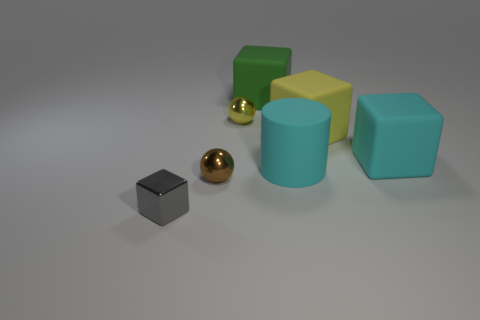Are there an equal number of tiny cubes that are in front of the big yellow matte thing and brown spheres in front of the tiny gray block?
Offer a very short reply. No. There is a metal ball behind the tiny sphere that is to the left of the small yellow metal ball; how big is it?
Ensure brevity in your answer.  Small. Are there any cyan rubber things that have the same size as the gray shiny object?
Your response must be concise. No. There is a cylinder that is the same material as the big green block; what color is it?
Provide a short and direct response. Cyan. Is the number of tiny brown cubes less than the number of yellow metallic spheres?
Your answer should be compact. Yes. What is the material of the block that is both left of the yellow cube and behind the large cyan cube?
Your response must be concise. Rubber. There is a shiny ball that is in front of the yellow block; are there any spheres that are in front of it?
Give a very brief answer. No. How many small metallic blocks have the same color as the cylinder?
Give a very brief answer. 0. There is a big cube that is the same color as the rubber cylinder; what material is it?
Offer a very short reply. Rubber. Are the brown object and the green thing made of the same material?
Ensure brevity in your answer.  No. 